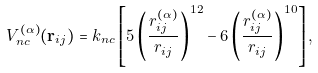Convert formula to latex. <formula><loc_0><loc_0><loc_500><loc_500>V _ { n c } ^ { ( \alpha ) } ( { \mathbf r } _ { i j } ) = k _ { n c } \left [ 5 \left ( \frac { r ^ { ( \alpha ) } _ { i j } } { r _ { i j } } \right ) ^ { 1 2 } - 6 \left ( \frac { r ^ { ( \alpha ) } _ { i j } } { r _ { i j } } \right ) ^ { 1 0 } \right ] ,</formula> 